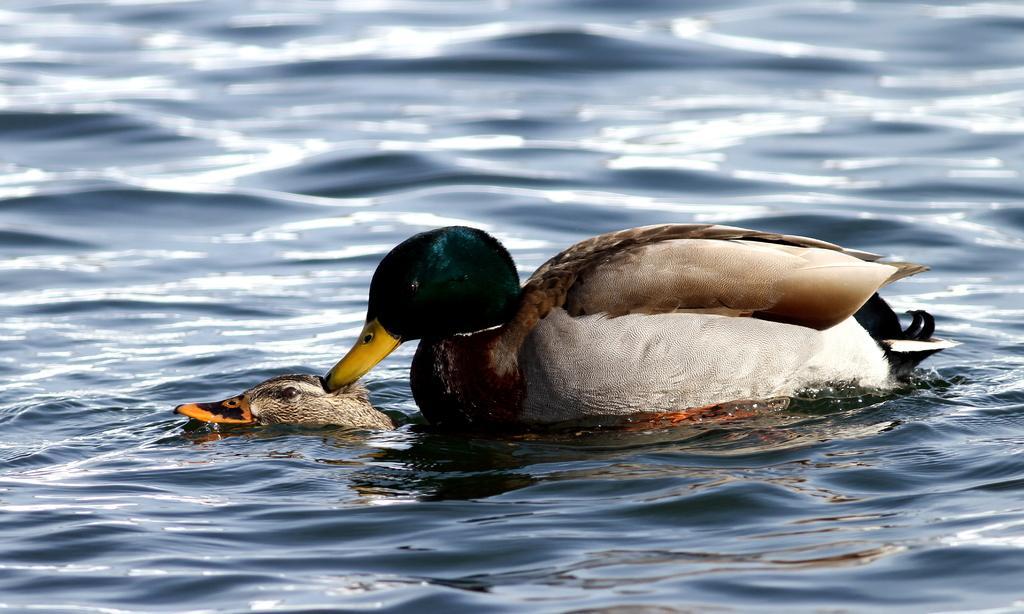Could you give a brief overview of what you see in this image? In the image we can see there are ducks swimming in the water. 